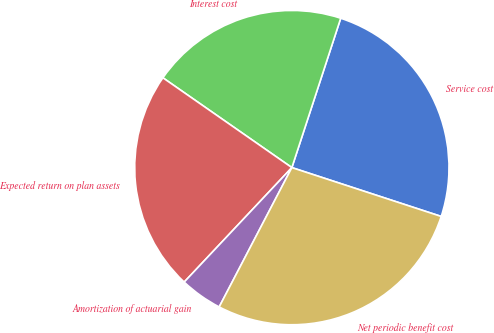Convert chart to OTSL. <chart><loc_0><loc_0><loc_500><loc_500><pie_chart><fcel>Service cost<fcel>Interest cost<fcel>Expected return on plan assets<fcel>Amortization of actuarial gain<fcel>Net periodic benefit cost<nl><fcel>25.0%<fcel>20.35%<fcel>22.67%<fcel>4.36%<fcel>27.62%<nl></chart> 